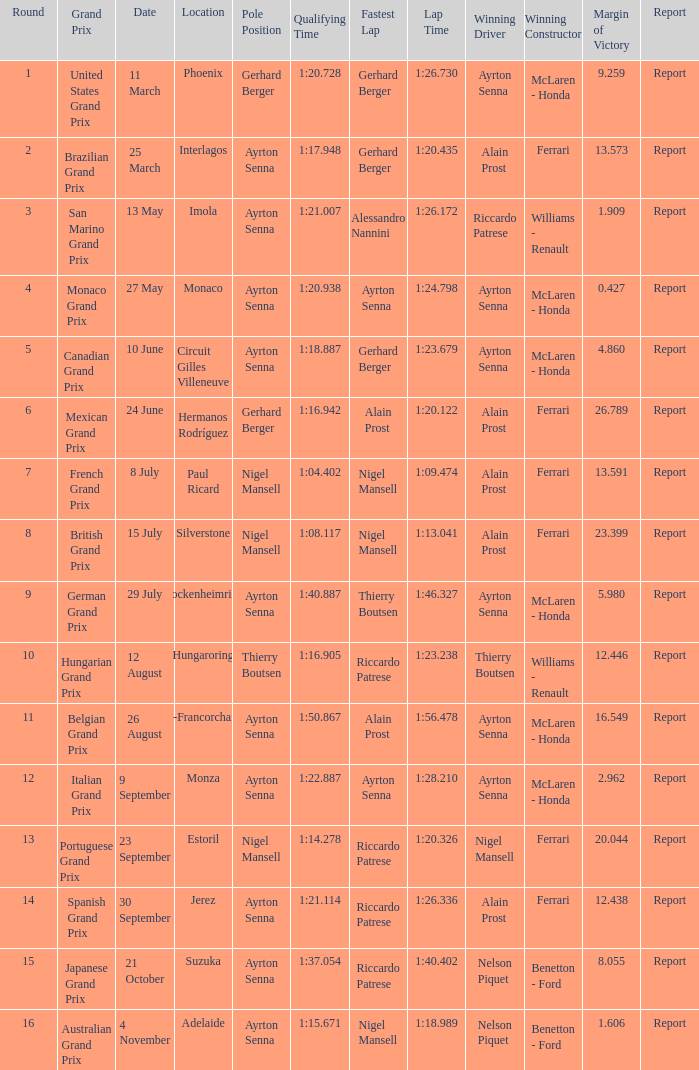What is the Pole Position for the German Grand Prix Ayrton Senna. 